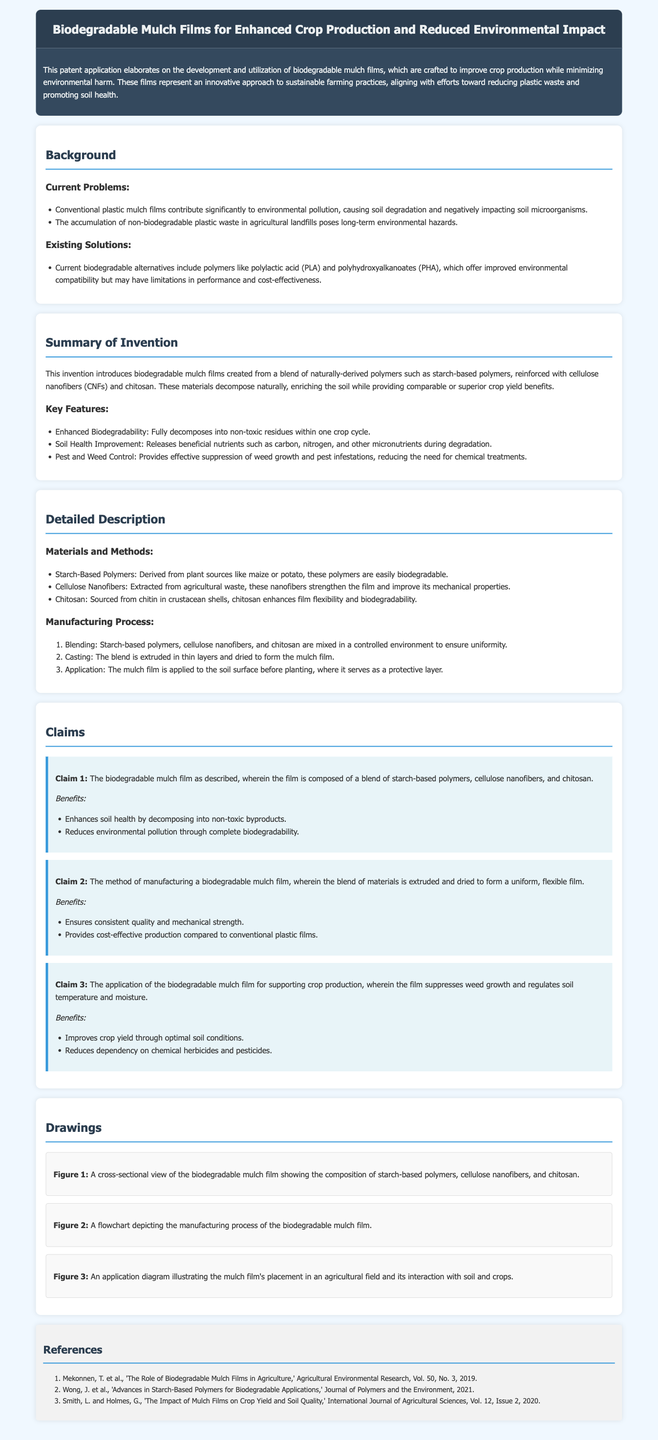what is the title of the patent application? The title of the patent application is presented at the top of the document.
Answer: Biodegradable Mulch Films for Enhanced Crop Production and Reduced Environmental Impact who are the authors of the references listed? The references section lists authors and their works related to biodegradable mulch films and agriculture.
Answer: Mekonnen, T.; Wong, J.; Smith, L.; Holmes, G what are the key features of the invention? The key features are specified in a dedicated section describing the benefits of the biodegradable mulch films.
Answer: Enhanced Biodegradability, Soil Health Improvement, Pest and Weed Control how many claims are included in the patent application? The claims section outlines the various claims made in the patent application.
Answer: Three which polymers are utilized in the biodegradable mulch films? A list of materials used in the biodegradable mulch films appears under the detailed description section.
Answer: Starch-based polymers, cellulose nanofibers, chitosan what is one benefit of the biodegradable mulch film regarding soil health? The benefits of the biodegradable mulch film are listed in relation to its effects on soil during degradation.
Answer: Releases beneficial nutrients what is the manufacturing process step after blending? The manufacturing process is described in a sequential format, guiding through the creation of the mulch film.
Answer: Casting what is the focus of the abstract? The abstract summarizes the main objective and significance of the invention.
Answer: Development and utilization of biodegradable mulch films how long does it take for the mulch film to fully decompose? The summary section provides a timeframe for the degradation of the mulch film.
Answer: One crop cycle 